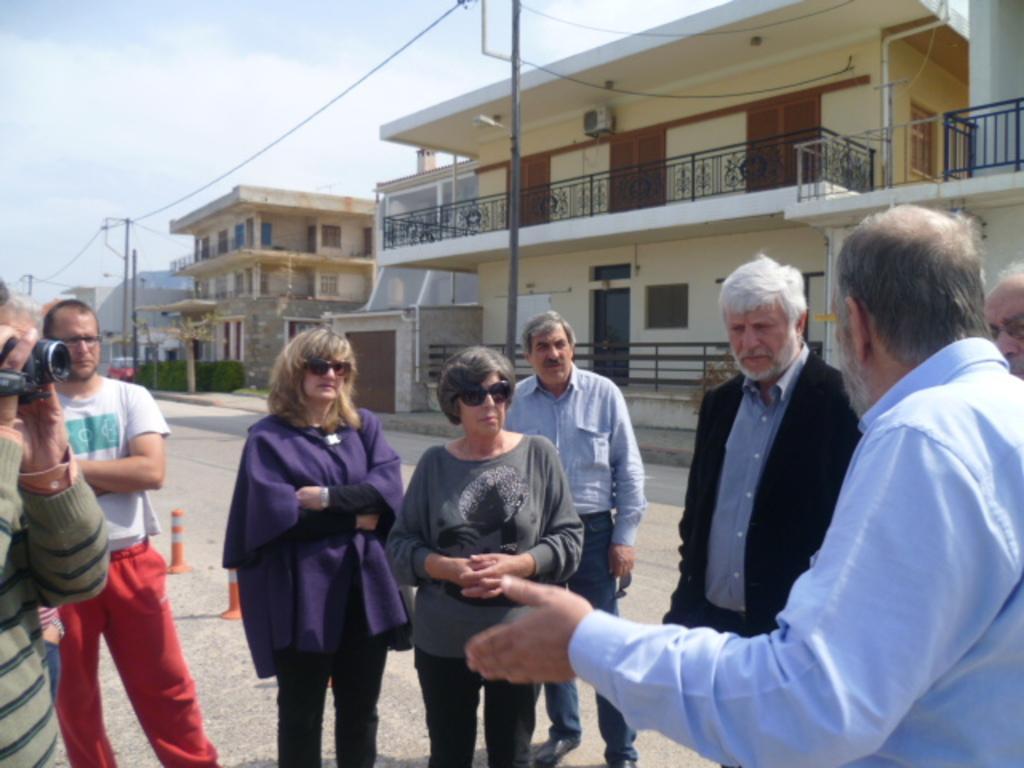Describe this image in one or two sentences. In the foreground of the image there are people standing. In the background of the image there are houses, electric poles. At the top of the image there is sky, clouds. At the bottom of the image there is road. To the left side of the image there is a person holding a camera. 